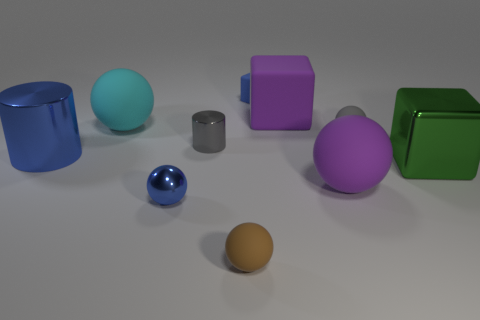There is a small shiny object behind the large ball on the right side of the small brown sphere; what color is it?
Ensure brevity in your answer.  Gray. Are there more tiny yellow shiny blocks than purple rubber things?
Make the answer very short. No. How many things are the same size as the gray matte ball?
Your response must be concise. 4. Does the tiny cube have the same material as the big ball that is behind the large green object?
Your answer should be compact. Yes. Is the number of gray cylinders less than the number of purple matte things?
Keep it short and to the point. Yes. Is there anything else that has the same color as the small metal ball?
Your answer should be compact. Yes. There is a blue thing that is the same material as the large cyan object; what is its shape?
Provide a short and direct response. Cube. There is a small metal object to the right of the small metallic object that is in front of the large purple ball; what number of big spheres are right of it?
Make the answer very short. 1. There is a matte object that is both in front of the gray cylinder and on the right side of the brown rubber sphere; what is its shape?
Offer a terse response. Sphere. Are there fewer rubber objects in front of the tiny gray ball than large metal cubes?
Make the answer very short. No. 